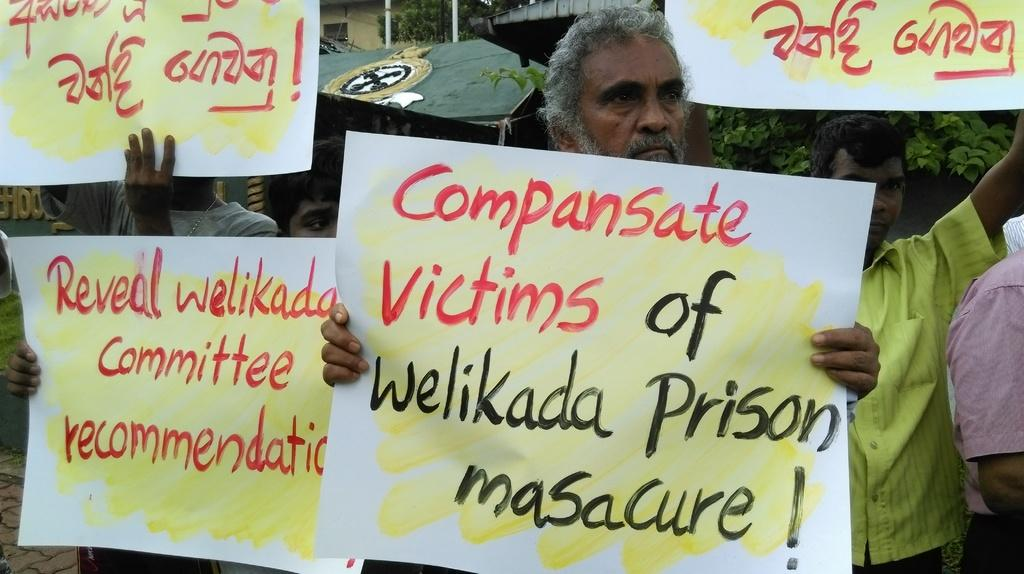What are the people in the image doing? The people in the image are standing and holding a banner. What is written on the banner? The banner has text on it. What can be seen in the background of the image? There are buildings, trees, and utility poles in the background of the image. What type of breakfast is being served on the table in the image? There is no table or breakfast present in the image; it features people holding a banner with text. What industry is represented by the letter on the banner? There is no letter or industry mentioned on the banner in the image. 